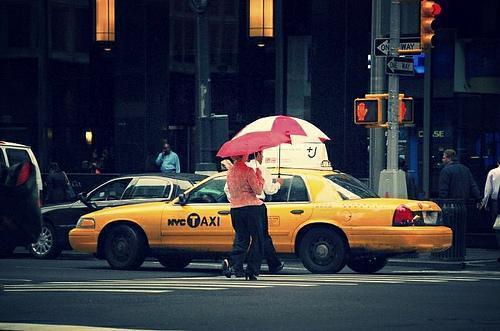How many people carry umbrellas?
Give a very brief answer. 2. 